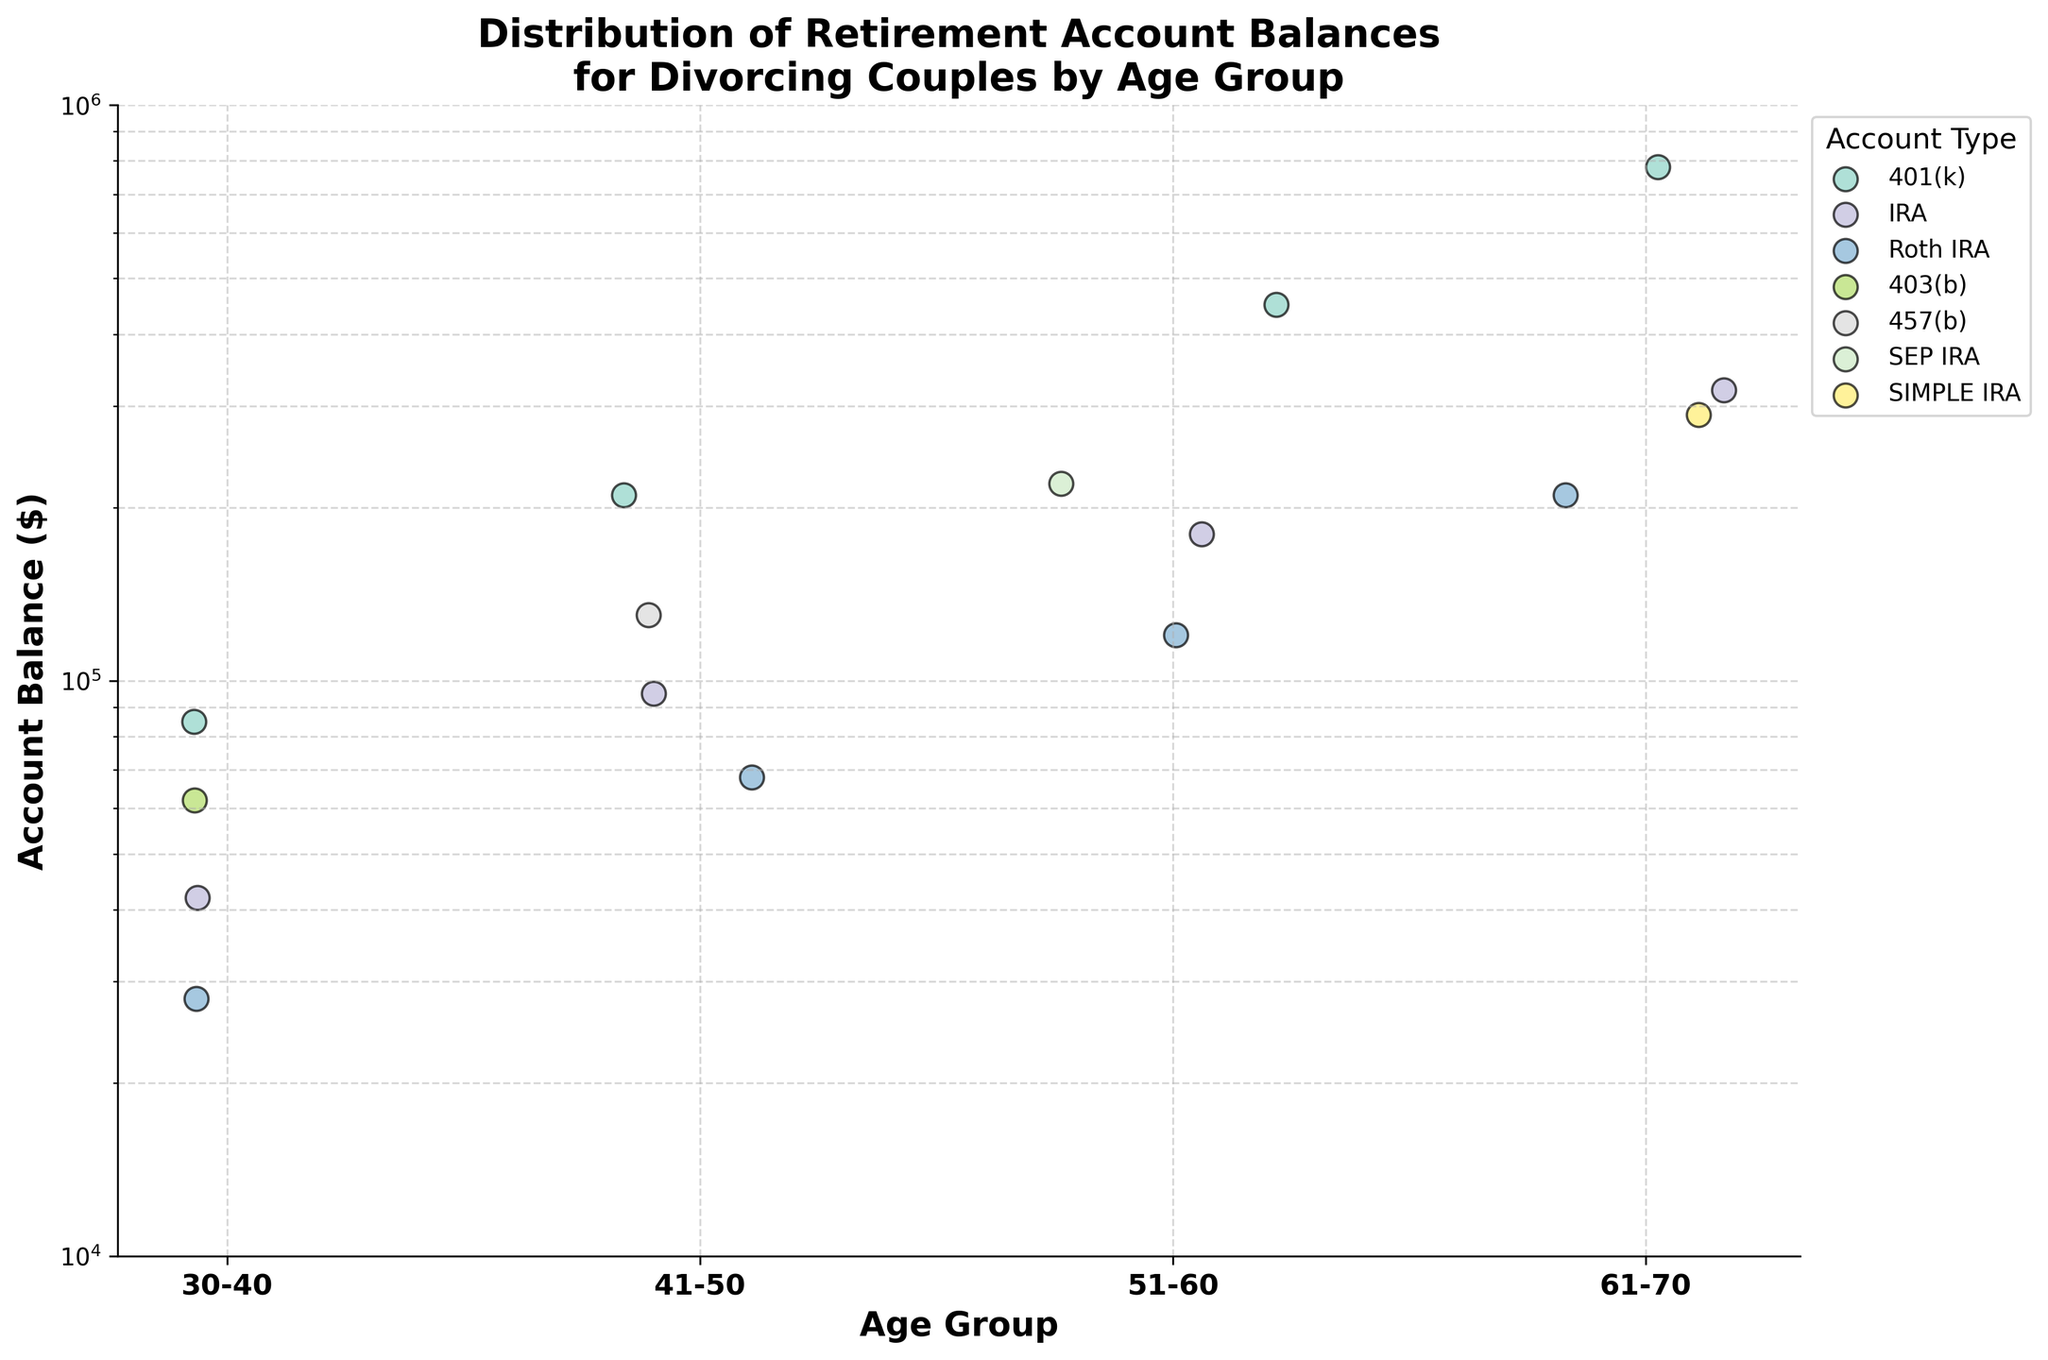How many age groups are shown in the plot? The plot labels on the x-axis represent the distinct age groups. They are listed as '30-40', '41-50', '51-60', and '61-70'.
Answer: Four What is the title of the plot? The title is located at the top of the plot and provides an overall description of what the plot illustrates. It reads, 'Distribution of Retirement Account Balances for Divorcing Couples by Age Group'.
Answer: Distribution of Retirement Account Balances for Divorcing Couples by Age Group Which retirement account type shows the highest balance for the 51-60 age group? By examining the plot, the dots representing the 51-60 age group can be identified. Among these dots, the highest positioned one corresponds to the '401(k)' account type with a balance of $450,000.
Answer: 401(k) What is the range of account balances for the 30-40 age group? Locate all the data points for the 30-40 age group on the plot. The lowest balance is $28,000 (Roth IRA), and the highest is $85,000 (401(k)). The range is the difference between these values.
Answer: $28,000 - $85,000 Compare the median balance of 401(k) accounts with that of IRA accounts across all age groups. Which one is higher? Identify the data points for 401(k) and IRA accounts across all age groups, then calculate the median for each. Balances for 401(k): 85,000, 210,000, 450,000, 780,000. Balances for IRA: 42,000, 95,000, 180,000, 320,000. Median for 401(k): (210,000+450,000)/2 = 330,000. Median for IRA: (95,000+180,000)/2 = 137,500.
Answer: 401(k) Among the age groups, which one shows the lowest overall account balance? Scan through the entire plot to identify the lowest data point, which belongs to the 30-40 age group with a Roth IRA balance of $28,000.
Answer: 30-40 How does the distribution of account balances change as age increases? Observe the account balance values across the age groups from 30-40 to 61-70. There is a notable increase in the range and average value of the account balances as the age increases.
Answer: Increases What is the difference in the highest account balances between the age groups 41-50 and 61-70? The highest balance for the 41-50 age group is $210,000 (401(k)), while for the 61-70 age group it is $780,000 (401(k)). The difference is 780,000 - 210,000.
Answer: $570,000 For which age group is the variability in IRA account balances the highest? Calculate the range for IRA account balances in each age group by finding the difference between their maximum and minimum balances. For 30-40: Range = $42,000 - $42,000 = $0; for 41-50: Range = $95,000 - $95,000 = $0; for 51-60: Range = $180,000 - $180,000 = $0; for 61-70: Range = $320,000 - $320,000 = $0. In this dataset, the variability for IRA accounts across age groups is not present as each age group's balance is represented by a single value.
Answer: None 